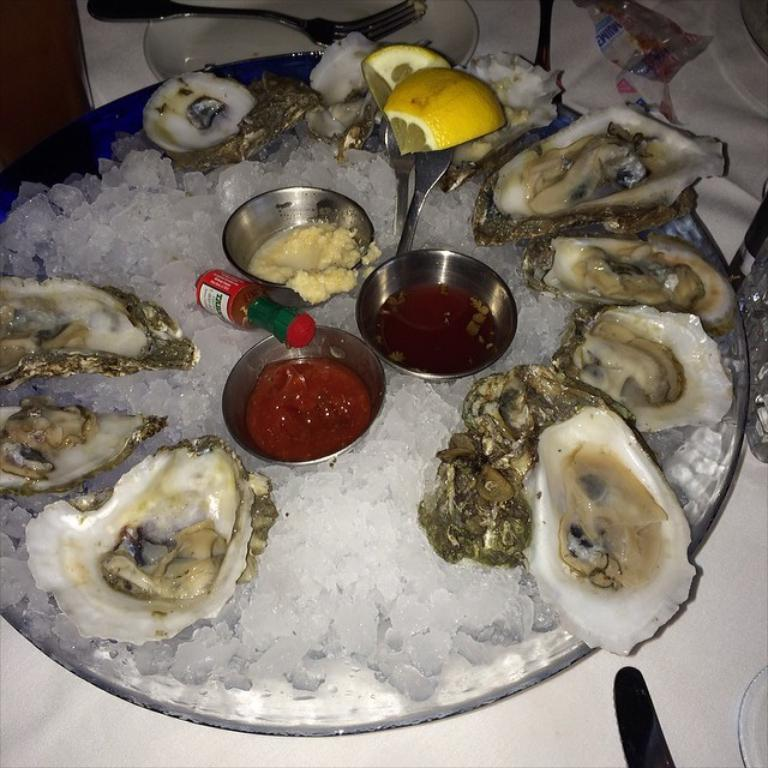What piece of furniture is present in the image? There is a table in the image. What items are on the table? There are plates and forks on the table. What else can be found on the table? There is a tray containing crushed ice, oysters, condiments, and lemon slices on the table. Where is the sheep grazing in the image? There is no sheep present in the image. What type of performance is taking place on the stage in the image? There is no stage present in the image. 